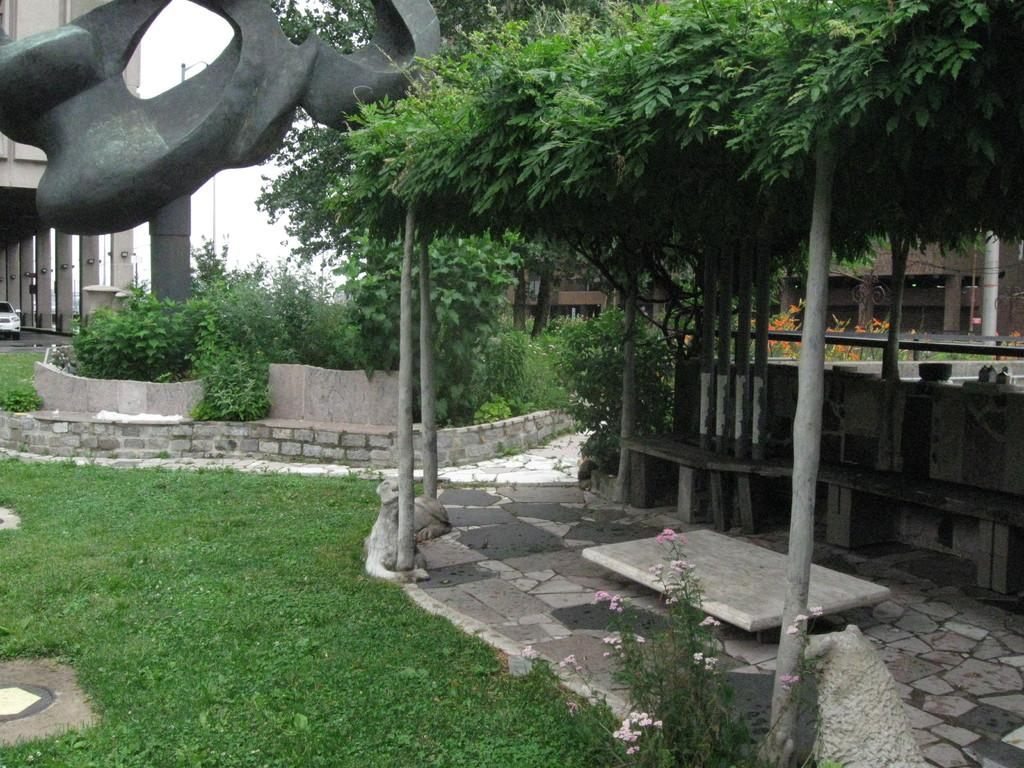What type of vegetation can be seen in the image? There is grass and plants in the image. What type of seating is available in the image? There are benches in the image. What kind of artwork is present in the image? There is a sculpture in the image. What is the color of the sculpture? The sculpture is cement in color. What type of structures are visible in the image? There are buildings in the image. What mode of transportation is present in the image? There is a vehicle in the image. How does the grass in the image feel to the touch? The image does not provide information about the texture or feeling of the grass, so it cannot be determined from the image. How many plants are present in the image? The image does not specify the exact number of plants, so it cannot be determined from the image. 